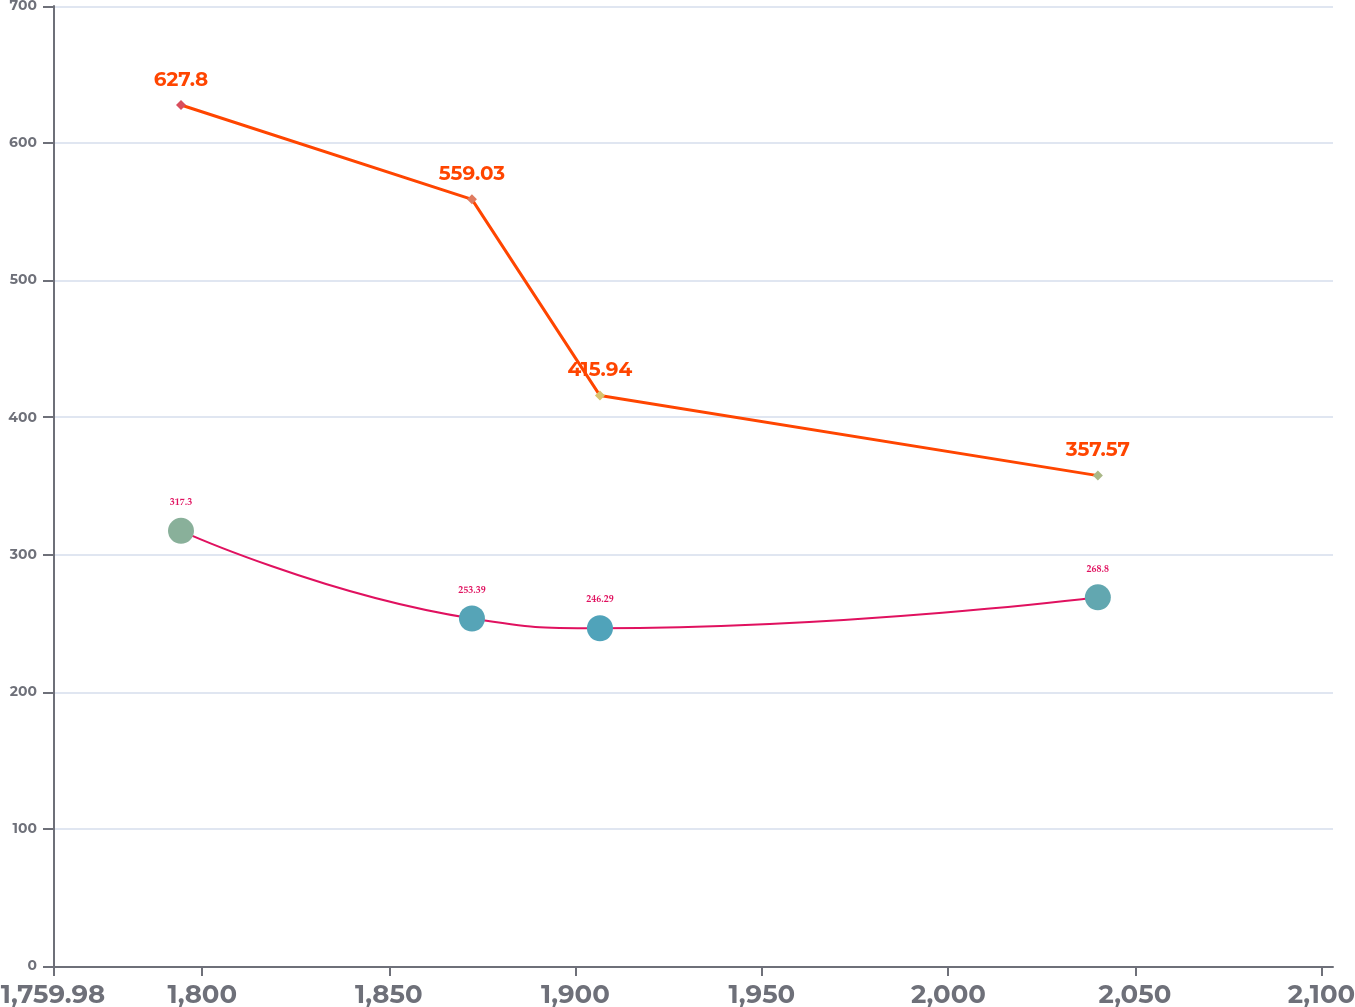Convert chart to OTSL. <chart><loc_0><loc_0><loc_500><loc_500><line_chart><ecel><fcel>Capital Leases<fcel>Operating Leases<nl><fcel>1794.29<fcel>627.8<fcel>317.3<nl><fcel>1872.28<fcel>559.03<fcel>253.39<nl><fcel>1906.59<fcel>415.94<fcel>246.29<nl><fcel>2040.05<fcel>357.57<fcel>268.8<nl><fcel>2137.39<fcel>327.54<fcel>288.96<nl></chart> 